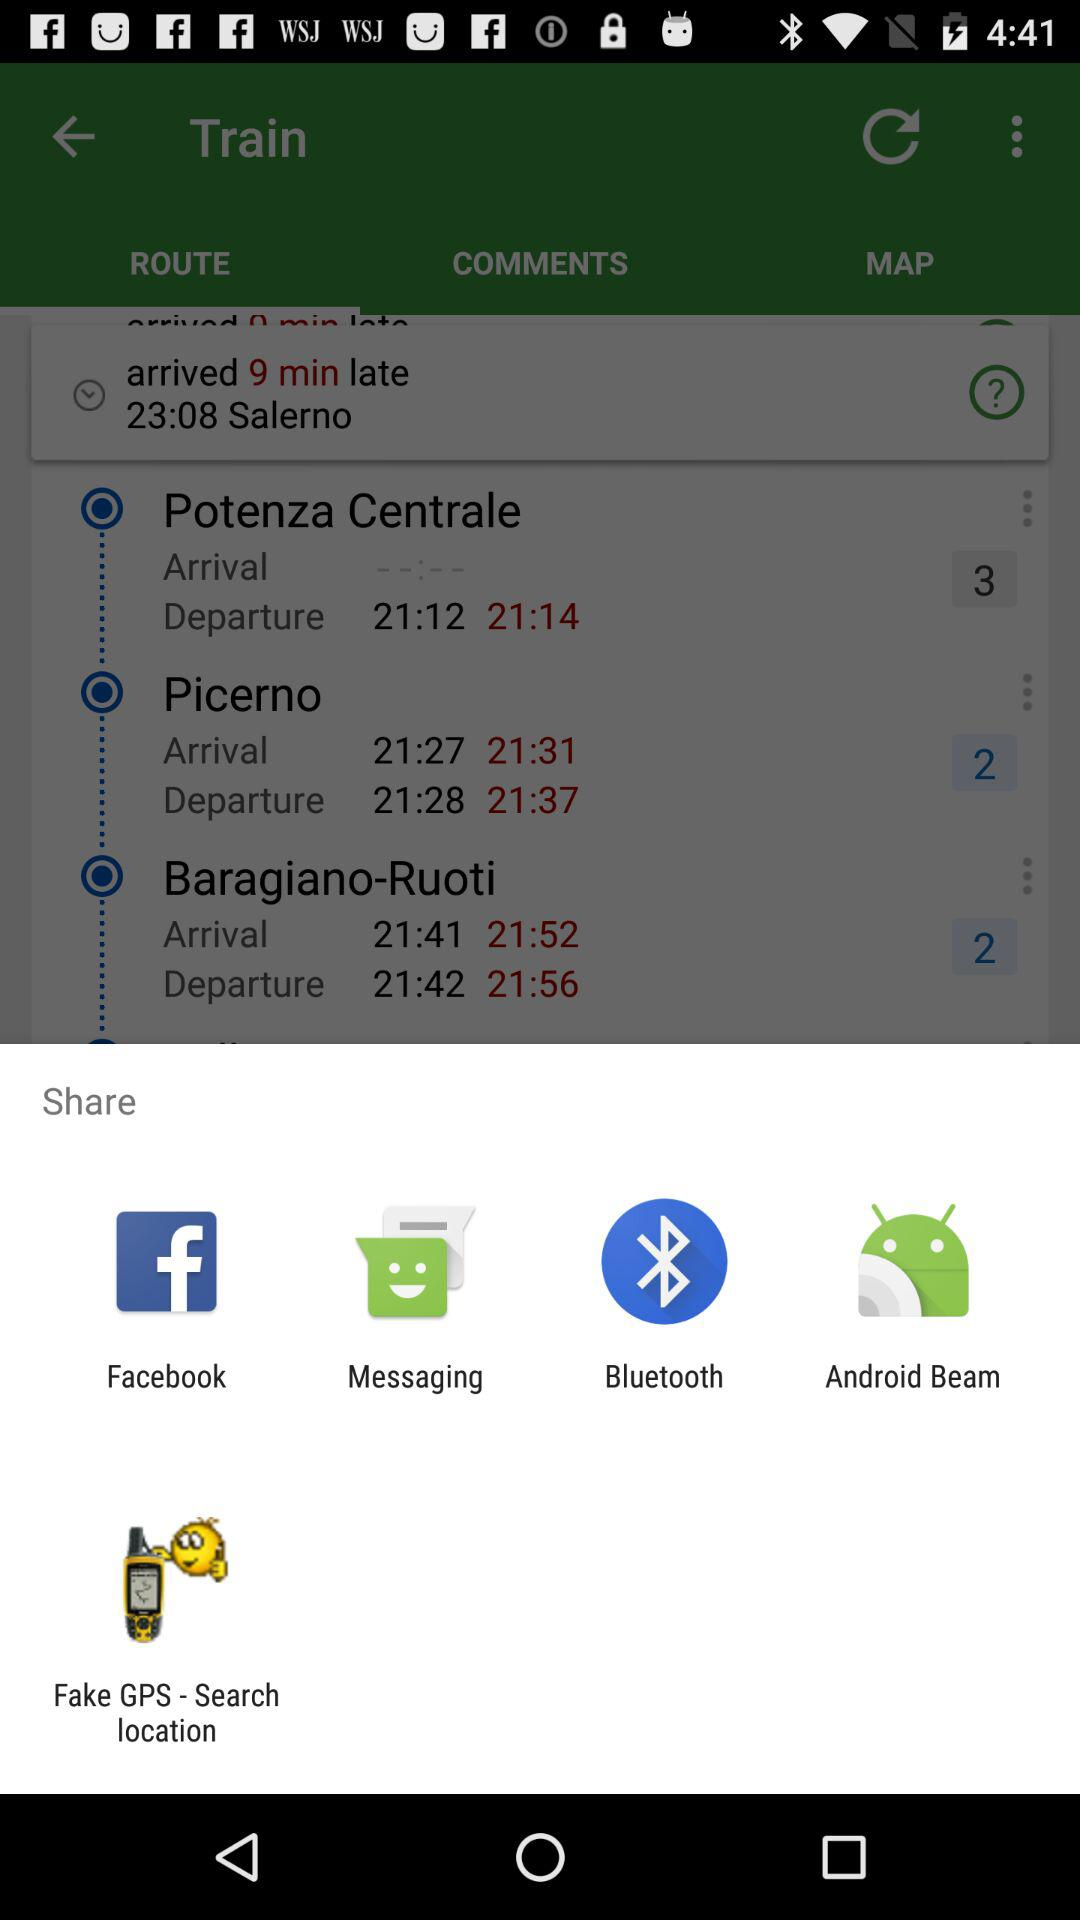Which maps are available in "MAP"?
When the provided information is insufficient, respond with <no answer>. <no answer> 